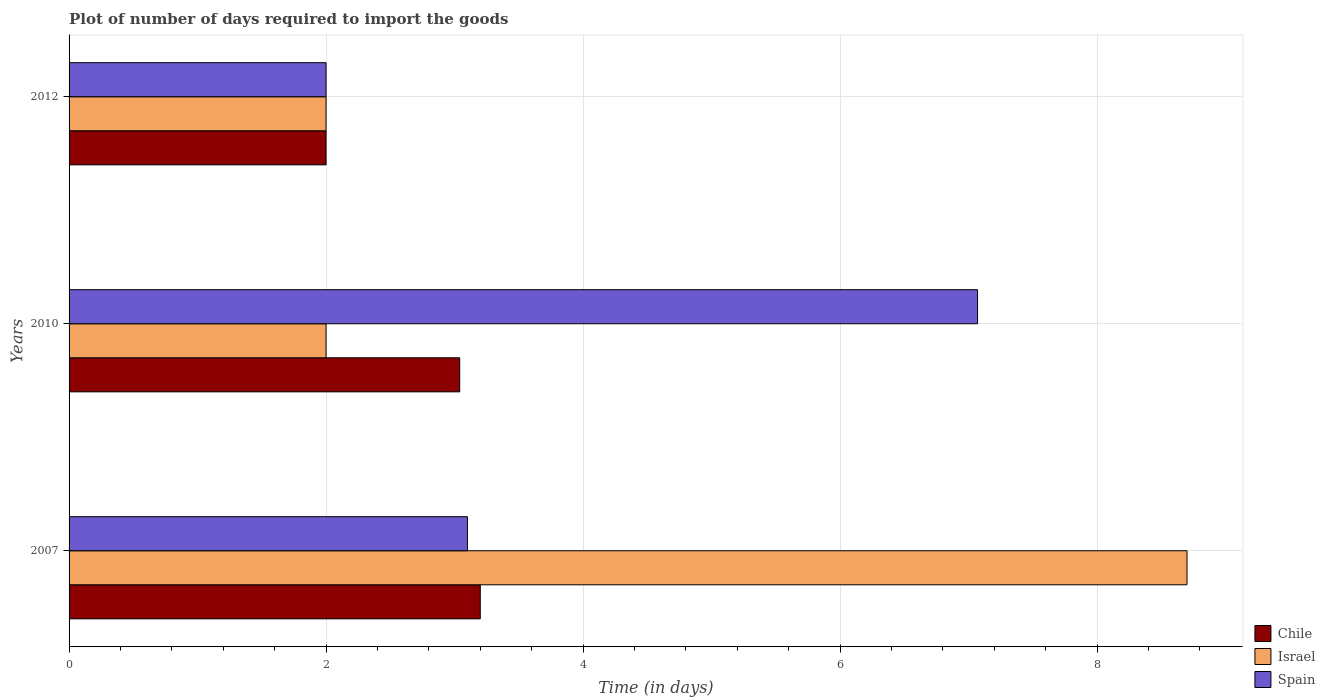Are the number of bars on each tick of the Y-axis equal?
Make the answer very short. Yes. How many bars are there on the 3rd tick from the top?
Ensure brevity in your answer.  3. How many bars are there on the 1st tick from the bottom?
Provide a short and direct response. 3. What is the time required to import goods in Chile in 2010?
Your response must be concise. 3.04. In which year was the time required to import goods in Spain minimum?
Ensure brevity in your answer.  2012. What is the total time required to import goods in Chile in the graph?
Offer a very short reply. 8.24. What is the difference between the time required to import goods in Spain in 2010 and the time required to import goods in Israel in 2007?
Give a very brief answer. -1.63. What is the average time required to import goods in Israel per year?
Ensure brevity in your answer.  4.23. In the year 2010, what is the difference between the time required to import goods in Israel and time required to import goods in Spain?
Offer a terse response. -5.07. In how many years, is the time required to import goods in Israel greater than 5.6 days?
Offer a very short reply. 1. What is the ratio of the time required to import goods in Spain in 2007 to that in 2012?
Offer a very short reply. 1.55. What is the difference between the highest and the second highest time required to import goods in Spain?
Your response must be concise. 3.97. What is the difference between the highest and the lowest time required to import goods in Israel?
Your answer should be very brief. 6.7. What does the 2nd bar from the top in 2007 represents?
Ensure brevity in your answer.  Israel. Are all the bars in the graph horizontal?
Offer a terse response. Yes. What is the difference between two consecutive major ticks on the X-axis?
Your answer should be compact. 2. Does the graph contain any zero values?
Give a very brief answer. No. How are the legend labels stacked?
Offer a very short reply. Vertical. What is the title of the graph?
Your answer should be very brief. Plot of number of days required to import the goods. Does "Euro area" appear as one of the legend labels in the graph?
Offer a very short reply. No. What is the label or title of the X-axis?
Offer a terse response. Time (in days). What is the label or title of the Y-axis?
Your response must be concise. Years. What is the Time (in days) of Israel in 2007?
Your answer should be very brief. 8.7. What is the Time (in days) in Chile in 2010?
Keep it short and to the point. 3.04. What is the Time (in days) in Spain in 2010?
Ensure brevity in your answer.  7.07. What is the Time (in days) of Spain in 2012?
Keep it short and to the point. 2. Across all years, what is the maximum Time (in days) in Israel?
Your answer should be compact. 8.7. Across all years, what is the maximum Time (in days) in Spain?
Make the answer very short. 7.07. Across all years, what is the minimum Time (in days) of Spain?
Your answer should be very brief. 2. What is the total Time (in days) of Chile in the graph?
Make the answer very short. 8.24. What is the total Time (in days) in Israel in the graph?
Your response must be concise. 12.7. What is the total Time (in days) of Spain in the graph?
Your answer should be very brief. 12.17. What is the difference between the Time (in days) in Chile in 2007 and that in 2010?
Your answer should be compact. 0.16. What is the difference between the Time (in days) in Israel in 2007 and that in 2010?
Ensure brevity in your answer.  6.7. What is the difference between the Time (in days) of Spain in 2007 and that in 2010?
Ensure brevity in your answer.  -3.97. What is the difference between the Time (in days) of Israel in 2010 and that in 2012?
Offer a very short reply. 0. What is the difference between the Time (in days) of Spain in 2010 and that in 2012?
Offer a terse response. 5.07. What is the difference between the Time (in days) of Chile in 2007 and the Time (in days) of Israel in 2010?
Make the answer very short. 1.2. What is the difference between the Time (in days) in Chile in 2007 and the Time (in days) in Spain in 2010?
Offer a terse response. -3.87. What is the difference between the Time (in days) of Israel in 2007 and the Time (in days) of Spain in 2010?
Make the answer very short. 1.63. What is the difference between the Time (in days) in Chile in 2007 and the Time (in days) in Israel in 2012?
Keep it short and to the point. 1.2. What is the average Time (in days) of Chile per year?
Your answer should be compact. 2.75. What is the average Time (in days) in Israel per year?
Offer a terse response. 4.23. What is the average Time (in days) of Spain per year?
Provide a short and direct response. 4.06. In the year 2007, what is the difference between the Time (in days) of Chile and Time (in days) of Israel?
Offer a very short reply. -5.5. In the year 2007, what is the difference between the Time (in days) of Israel and Time (in days) of Spain?
Your answer should be very brief. 5.6. In the year 2010, what is the difference between the Time (in days) of Chile and Time (in days) of Spain?
Give a very brief answer. -4.03. In the year 2010, what is the difference between the Time (in days) in Israel and Time (in days) in Spain?
Your response must be concise. -5.07. In the year 2012, what is the difference between the Time (in days) in Chile and Time (in days) in Israel?
Provide a succinct answer. 0. In the year 2012, what is the difference between the Time (in days) in Chile and Time (in days) in Spain?
Keep it short and to the point. 0. What is the ratio of the Time (in days) in Chile in 2007 to that in 2010?
Give a very brief answer. 1.05. What is the ratio of the Time (in days) in Israel in 2007 to that in 2010?
Provide a succinct answer. 4.35. What is the ratio of the Time (in days) of Spain in 2007 to that in 2010?
Ensure brevity in your answer.  0.44. What is the ratio of the Time (in days) of Israel in 2007 to that in 2012?
Make the answer very short. 4.35. What is the ratio of the Time (in days) in Spain in 2007 to that in 2012?
Ensure brevity in your answer.  1.55. What is the ratio of the Time (in days) of Chile in 2010 to that in 2012?
Your answer should be very brief. 1.52. What is the ratio of the Time (in days) in Spain in 2010 to that in 2012?
Keep it short and to the point. 3.54. What is the difference between the highest and the second highest Time (in days) in Chile?
Offer a very short reply. 0.16. What is the difference between the highest and the second highest Time (in days) of Israel?
Make the answer very short. 6.7. What is the difference between the highest and the second highest Time (in days) in Spain?
Offer a terse response. 3.97. What is the difference between the highest and the lowest Time (in days) of Chile?
Your response must be concise. 1.2. What is the difference between the highest and the lowest Time (in days) in Israel?
Offer a terse response. 6.7. What is the difference between the highest and the lowest Time (in days) in Spain?
Make the answer very short. 5.07. 